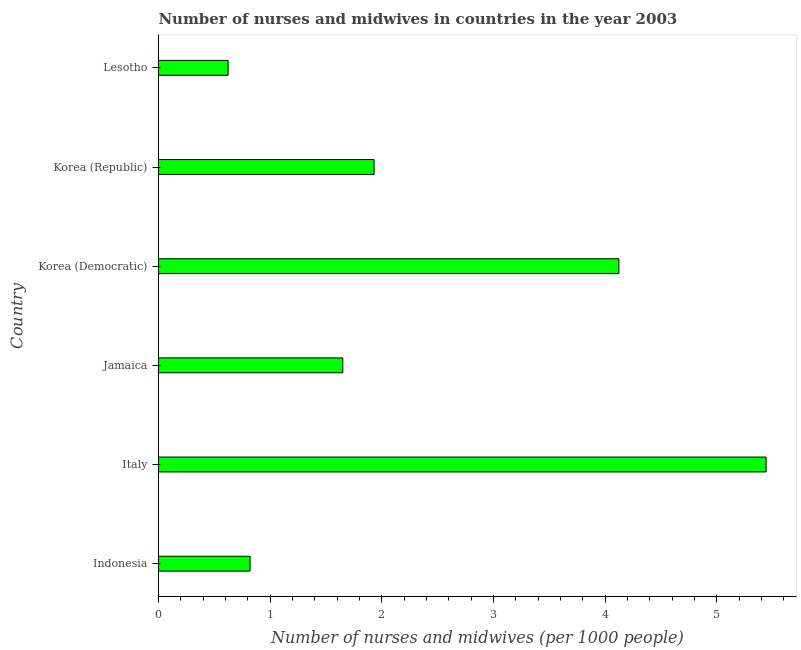Does the graph contain any zero values?
Offer a very short reply. No. What is the title of the graph?
Make the answer very short. Number of nurses and midwives in countries in the year 2003. What is the label or title of the X-axis?
Make the answer very short. Number of nurses and midwives (per 1000 people). What is the label or title of the Y-axis?
Your response must be concise. Country. What is the number of nurses and midwives in Lesotho?
Make the answer very short. 0.62. Across all countries, what is the maximum number of nurses and midwives?
Offer a terse response. 5.44. Across all countries, what is the minimum number of nurses and midwives?
Ensure brevity in your answer.  0.62. In which country was the number of nurses and midwives minimum?
Provide a succinct answer. Lesotho. What is the sum of the number of nurses and midwives?
Offer a very short reply. 14.58. What is the difference between the number of nurses and midwives in Italy and Lesotho?
Your answer should be compact. 4.82. What is the average number of nurses and midwives per country?
Make the answer very short. 2.43. What is the median number of nurses and midwives?
Offer a terse response. 1.79. In how many countries, is the number of nurses and midwives greater than 5.4 ?
Your answer should be very brief. 1. What is the ratio of the number of nurses and midwives in Korea (Republic) to that in Lesotho?
Ensure brevity in your answer.  3.1. Is the number of nurses and midwives in Italy less than that in Korea (Republic)?
Keep it short and to the point. No. Is the difference between the number of nurses and midwives in Jamaica and Korea (Democratic) greater than the difference between any two countries?
Offer a terse response. No. What is the difference between the highest and the second highest number of nurses and midwives?
Keep it short and to the point. 1.32. What is the difference between the highest and the lowest number of nurses and midwives?
Your answer should be compact. 4.82. In how many countries, is the number of nurses and midwives greater than the average number of nurses and midwives taken over all countries?
Ensure brevity in your answer.  2. How many bars are there?
Provide a short and direct response. 6. Are all the bars in the graph horizontal?
Provide a short and direct response. Yes. How many countries are there in the graph?
Your answer should be very brief. 6. Are the values on the major ticks of X-axis written in scientific E-notation?
Your answer should be very brief. No. What is the Number of nurses and midwives (per 1000 people) in Indonesia?
Your response must be concise. 0.82. What is the Number of nurses and midwives (per 1000 people) in Italy?
Your response must be concise. 5.44. What is the Number of nurses and midwives (per 1000 people) in Jamaica?
Your answer should be compact. 1.65. What is the Number of nurses and midwives (per 1000 people) of Korea (Democratic)?
Give a very brief answer. 4.12. What is the Number of nurses and midwives (per 1000 people) in Korea (Republic)?
Keep it short and to the point. 1.93. What is the Number of nurses and midwives (per 1000 people) of Lesotho?
Provide a short and direct response. 0.62. What is the difference between the Number of nurses and midwives (per 1000 people) in Indonesia and Italy?
Make the answer very short. -4.62. What is the difference between the Number of nurses and midwives (per 1000 people) in Indonesia and Jamaica?
Your answer should be very brief. -0.83. What is the difference between the Number of nurses and midwives (per 1000 people) in Indonesia and Korea (Democratic)?
Offer a very short reply. -3.3. What is the difference between the Number of nurses and midwives (per 1000 people) in Indonesia and Korea (Republic)?
Ensure brevity in your answer.  -1.11. What is the difference between the Number of nurses and midwives (per 1000 people) in Indonesia and Lesotho?
Your answer should be very brief. 0.2. What is the difference between the Number of nurses and midwives (per 1000 people) in Italy and Jamaica?
Your response must be concise. 3.79. What is the difference between the Number of nurses and midwives (per 1000 people) in Italy and Korea (Democratic)?
Make the answer very short. 1.32. What is the difference between the Number of nurses and midwives (per 1000 people) in Italy and Korea (Republic)?
Offer a terse response. 3.51. What is the difference between the Number of nurses and midwives (per 1000 people) in Italy and Lesotho?
Provide a succinct answer. 4.82. What is the difference between the Number of nurses and midwives (per 1000 people) in Jamaica and Korea (Democratic)?
Make the answer very short. -2.47. What is the difference between the Number of nurses and midwives (per 1000 people) in Jamaica and Korea (Republic)?
Your answer should be very brief. -0.28. What is the difference between the Number of nurses and midwives (per 1000 people) in Jamaica and Lesotho?
Your answer should be very brief. 1.03. What is the difference between the Number of nurses and midwives (per 1000 people) in Korea (Democratic) and Korea (Republic)?
Your response must be concise. 2.19. What is the difference between the Number of nurses and midwives (per 1000 people) in Korea (Democratic) and Lesotho?
Your response must be concise. 3.5. What is the difference between the Number of nurses and midwives (per 1000 people) in Korea (Republic) and Lesotho?
Keep it short and to the point. 1.31. What is the ratio of the Number of nurses and midwives (per 1000 people) in Indonesia to that in Italy?
Offer a terse response. 0.15. What is the ratio of the Number of nurses and midwives (per 1000 people) in Indonesia to that in Jamaica?
Your response must be concise. 0.5. What is the ratio of the Number of nurses and midwives (per 1000 people) in Indonesia to that in Korea (Democratic)?
Ensure brevity in your answer.  0.2. What is the ratio of the Number of nurses and midwives (per 1000 people) in Indonesia to that in Korea (Republic)?
Make the answer very short. 0.42. What is the ratio of the Number of nurses and midwives (per 1000 people) in Indonesia to that in Lesotho?
Keep it short and to the point. 1.32. What is the ratio of the Number of nurses and midwives (per 1000 people) in Italy to that in Jamaica?
Your response must be concise. 3.3. What is the ratio of the Number of nurses and midwives (per 1000 people) in Italy to that in Korea (Democratic)?
Make the answer very short. 1.32. What is the ratio of the Number of nurses and midwives (per 1000 people) in Italy to that in Korea (Republic)?
Keep it short and to the point. 2.82. What is the ratio of the Number of nurses and midwives (per 1000 people) in Italy to that in Lesotho?
Offer a terse response. 8.73. What is the ratio of the Number of nurses and midwives (per 1000 people) in Jamaica to that in Korea (Republic)?
Give a very brief answer. 0.85. What is the ratio of the Number of nurses and midwives (per 1000 people) in Jamaica to that in Lesotho?
Your answer should be very brief. 2.65. What is the ratio of the Number of nurses and midwives (per 1000 people) in Korea (Democratic) to that in Korea (Republic)?
Give a very brief answer. 2.14. What is the ratio of the Number of nurses and midwives (per 1000 people) in Korea (Democratic) to that in Lesotho?
Ensure brevity in your answer.  6.62. What is the ratio of the Number of nurses and midwives (per 1000 people) in Korea (Republic) to that in Lesotho?
Provide a short and direct response. 3.1. 